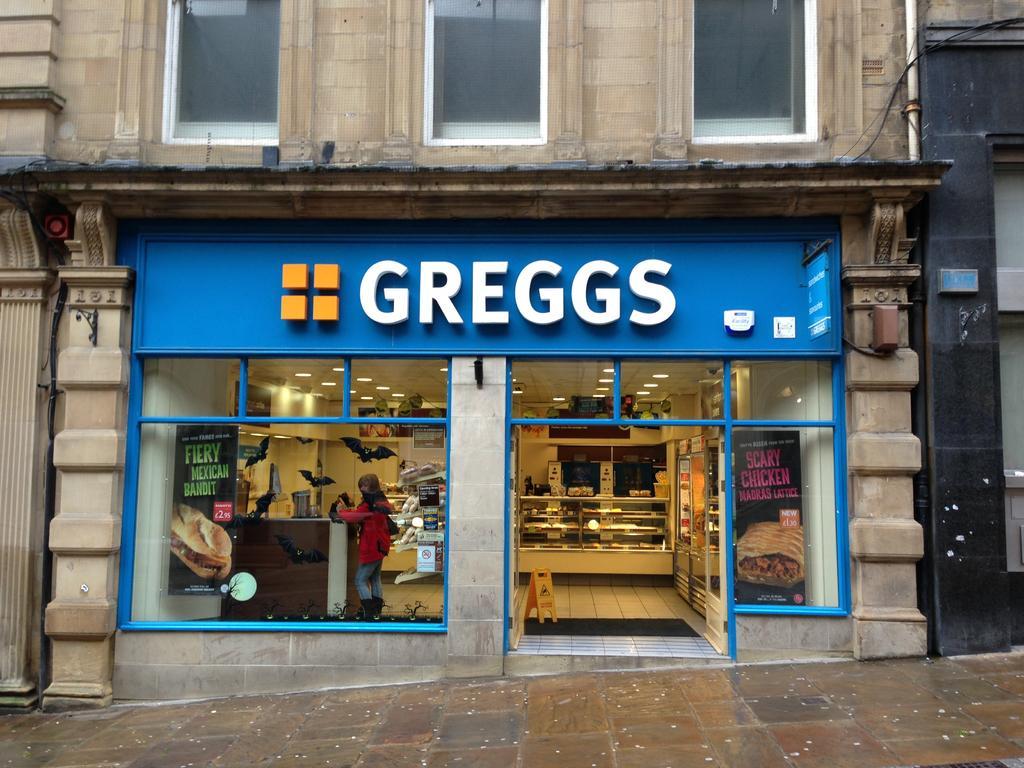Describe this image in one or two sentences. In this picture we can see few lights, and a woman in the store, and also we can see a pipe on the building. 